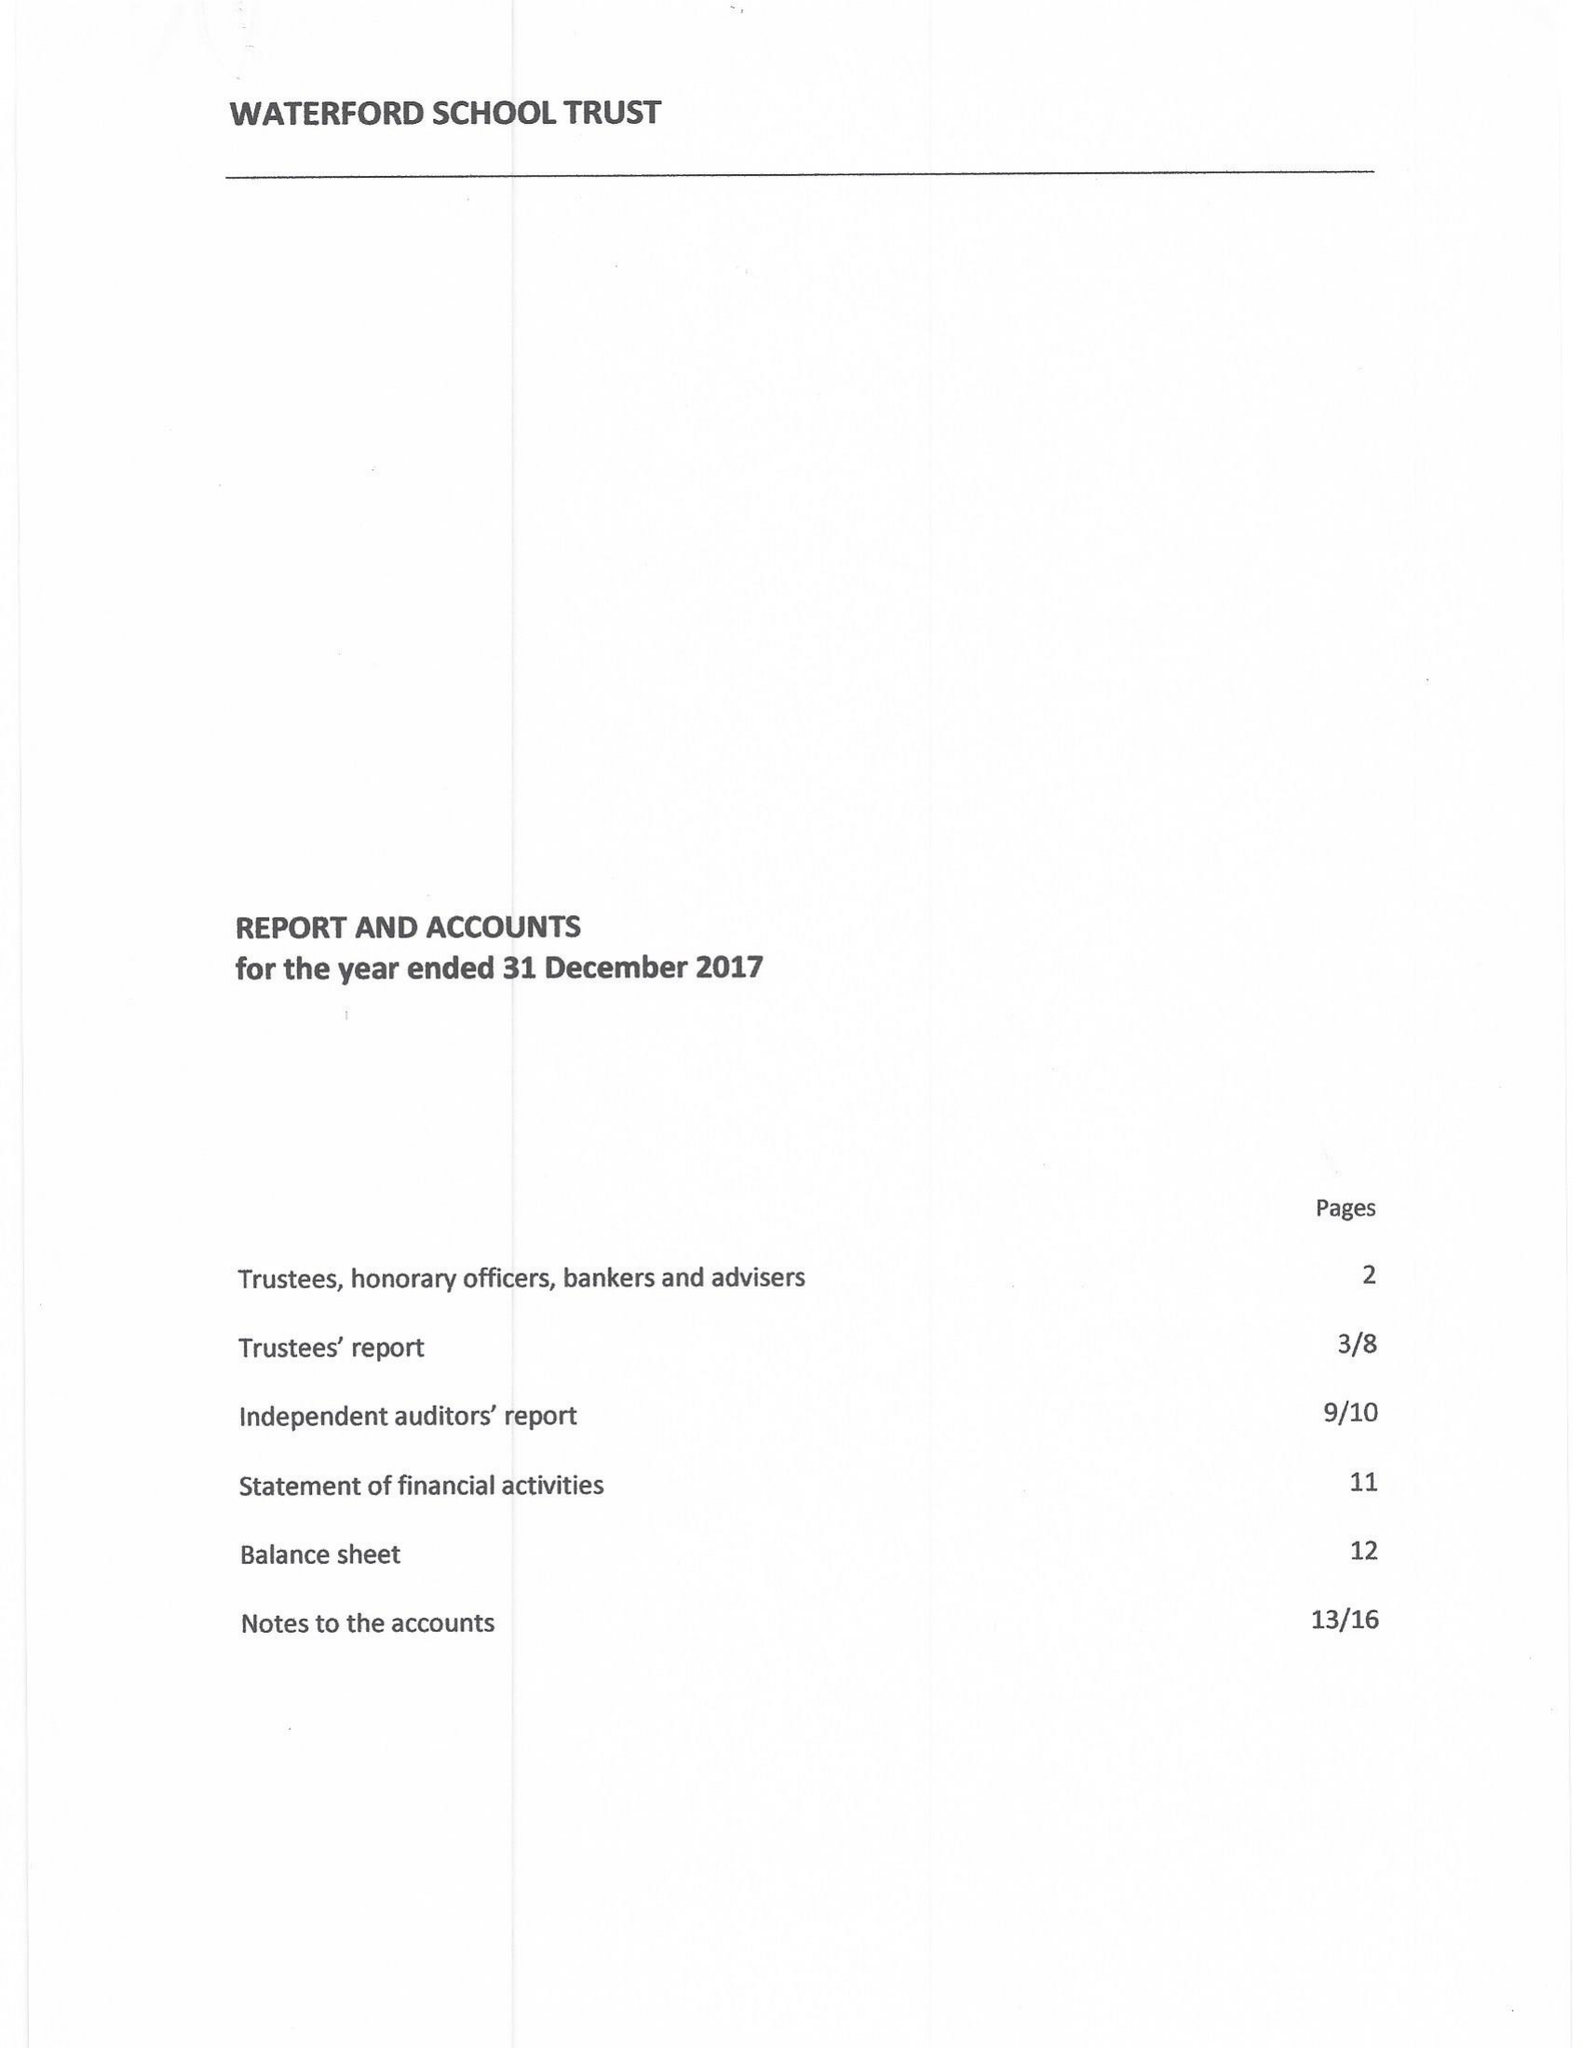What is the value for the address__street_line?
Answer the question using a single word or phrase. 13 COLLEGE LANE 